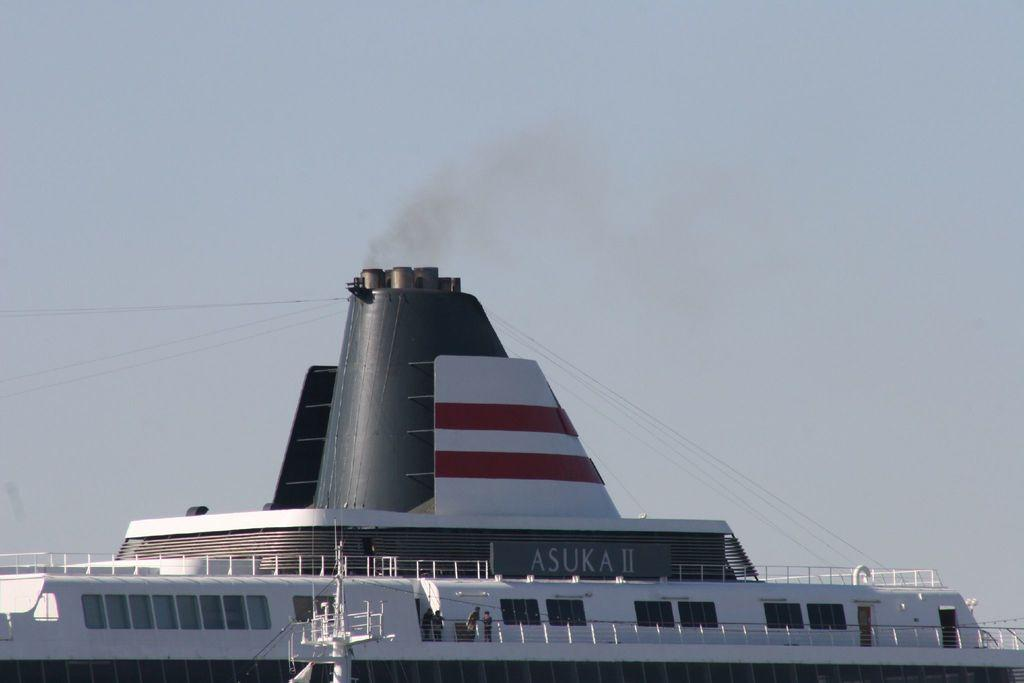What is the main subject of the picture? The main subject of the picture is a ship. What are the people on the ship doing? The people are standing behind the railing on the ship. What can be seen on the ship besides the people? There is text on the ship. What is visible at the top of the image? The sky is visible at the top of the image. What else is present in the image besides the ship and people? There are wires in the image. How many spiders are crawling on the ship in the image? There are no spiders visible in the image; the focus is on the ship, people, text, sky, and wires. 